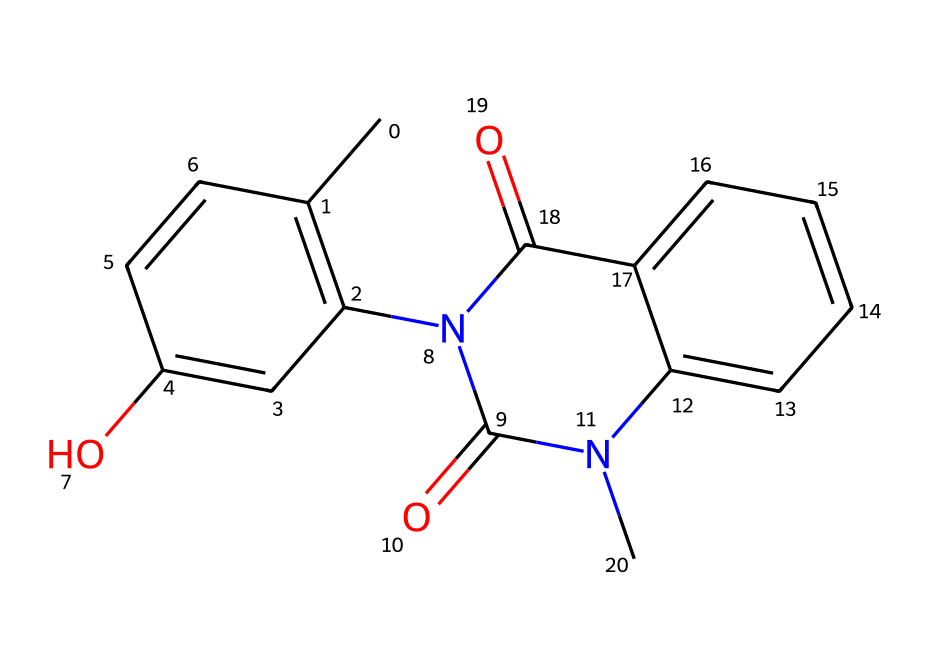What is the molecular formula of this compound? To determine the molecular formula, count the number of each type of atom in the SMILES representation. The analysis reveals that there are 18 carbon atoms, 16 hydrogen atoms, 4 oxygen atoms, and 2 nitrogen atoms present. Therefore, the molecular formula is C18H16N2O4.
Answer: C18H16N2O4 How many nitrogen atoms are in this compound? The SMILES structure contains two occurrences of the nitrogen atom (N). By directly identifying N in the representation, we confirm that there are two nitrogen atoms present in the structure.
Answer: 2 What type of chemical structure does this represent? The presence of nitrogen and a complex ring system suggests that this compound belongs to the class of drugs known as heterocycles, specifically with characteristics typical of alkaloids. This reasoning is based on the presence of both carbon and nitrogen in the cyclic structures.
Answer: alkaloid What functional groups can be identified in this compound? By examining the structure, we can identify several functional groups. The presence of the -OH group indicates a phenolic or alcohol functional group, while the -N(C)- (tertiary amine) indicates the involvement of nitrogen. Hence, the identified functional groups are hydroxyl and amine.
Answer: hydroxyl and amine Is this compound likely to dissolve in water? The presence of polar functional groups, particularly the hydroxyl (-OH) and amine groups, suggests that this compound may be soluble in water. Polar groups often enhance solubility due to their ability to form hydrogen bonds with water molecules.
Answer: likely Which part of this chemical is primarily responsible for its biological activity? The presence of the nitrogen atoms in the structure, particularly in the cyclic portion, indicates that these sites are significant for its biological interactions, typical of many drugs. This involvement often correlates with the compound's pharmacological properties.
Answer: nitrogen atoms 